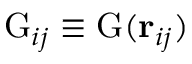<formula> <loc_0><loc_0><loc_500><loc_500>G _ { i j } \equiv G ( r _ { i j } )</formula> 